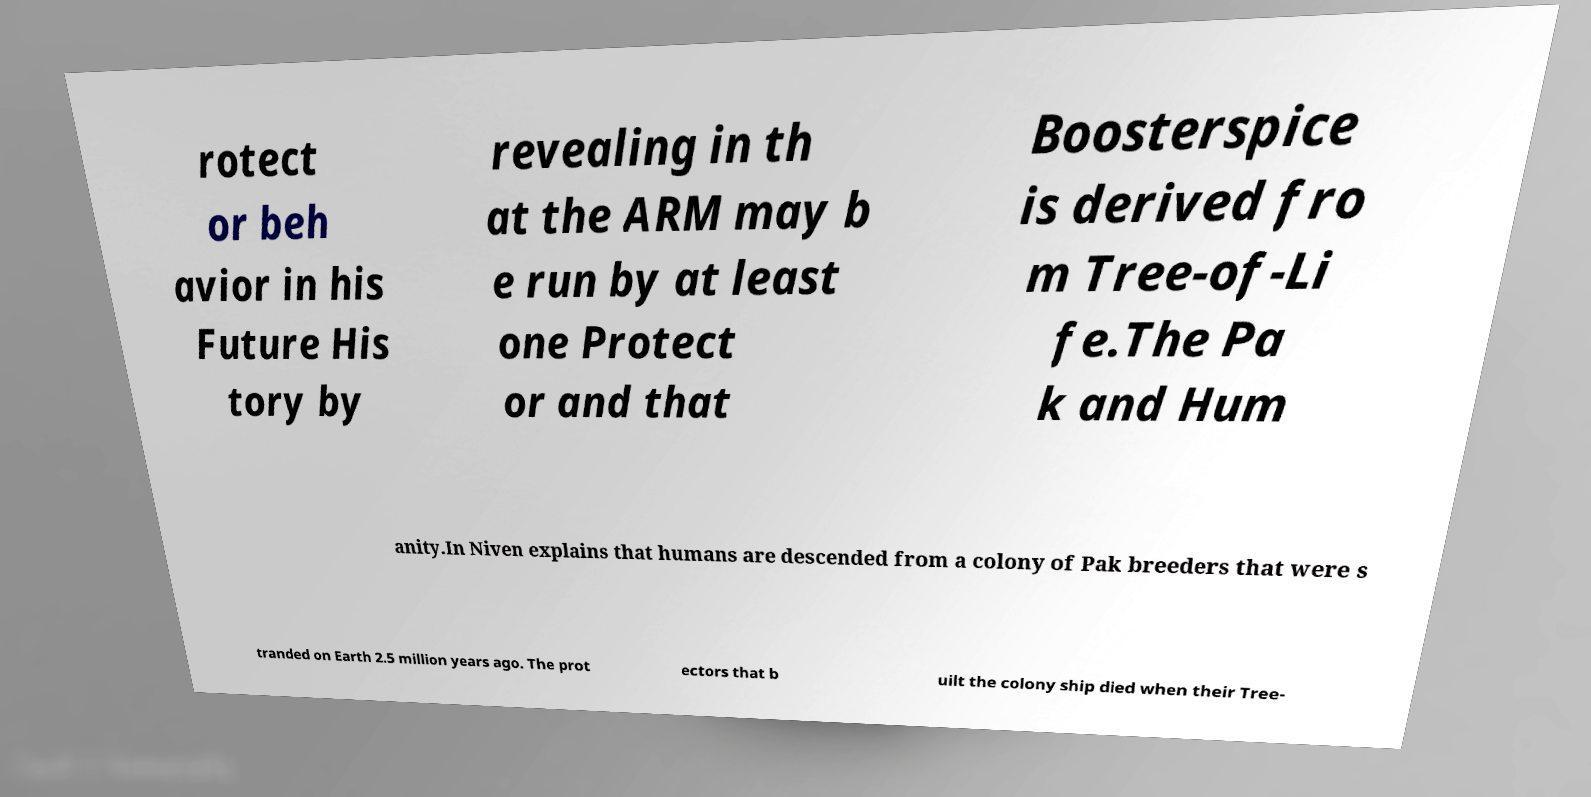Can you read and provide the text displayed in the image?This photo seems to have some interesting text. Can you extract and type it out for me? rotect or beh avior in his Future His tory by revealing in th at the ARM may b e run by at least one Protect or and that Boosterspice is derived fro m Tree-of-Li fe.The Pa k and Hum anity.In Niven explains that humans are descended from a colony of Pak breeders that were s tranded on Earth 2.5 million years ago. The prot ectors that b uilt the colony ship died when their Tree- 